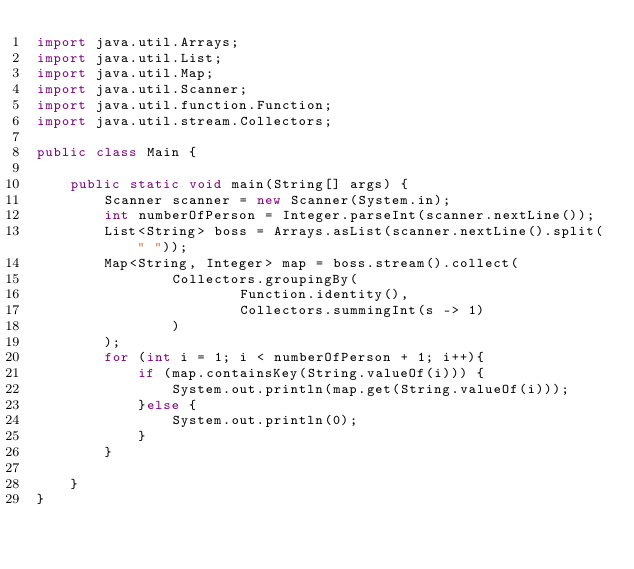Convert code to text. <code><loc_0><loc_0><loc_500><loc_500><_Java_>import java.util.Arrays;
import java.util.List;
import java.util.Map;
import java.util.Scanner;
import java.util.function.Function;
import java.util.stream.Collectors;

public class Main {

    public static void main(String[] args) {
        Scanner scanner = new Scanner(System.in);
        int numberOfPerson = Integer.parseInt(scanner.nextLine());
        List<String> boss = Arrays.asList(scanner.nextLine().split(" "));
        Map<String, Integer> map = boss.stream().collect(
                Collectors.groupingBy(
                        Function.identity(),
                        Collectors.summingInt(s -> 1)
                )
        );
        for (int i = 1; i < numberOfPerson + 1; i++){
            if (map.containsKey(String.valueOf(i))) {
                System.out.println(map.get(String.valueOf(i)));
            }else {
                System.out.println(0);
            }
        }

    }
}</code> 